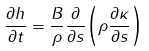Convert formula to latex. <formula><loc_0><loc_0><loc_500><loc_500>\frac { \partial h } { \partial t } = \frac { B } { \rho } \frac { \partial } { \partial s } { \left ( \rho \frac { \partial \kappa } { \partial s } \right ) }</formula> 